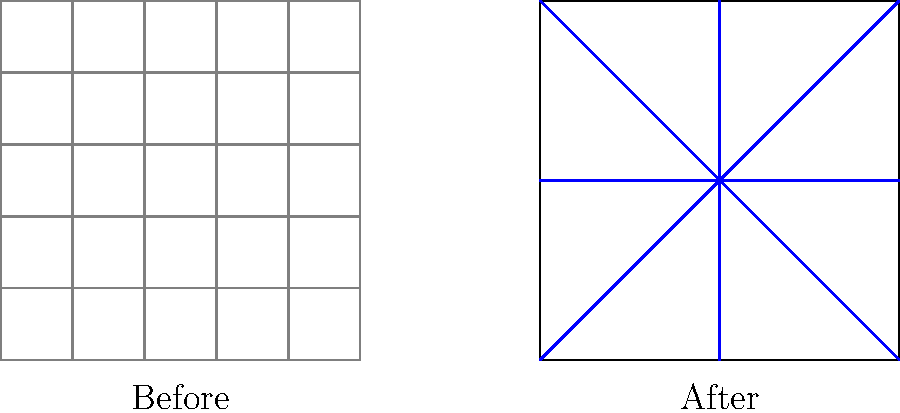In the evolution of urban planning principles, what key concept is illustrated by the transition from the "Before" to the "After" city grid, and how does it potentially impact the functionality and aesthetics of the urban environment? 1. Observe the "Before" grid:
   - It shows a rigid, rectangular grid system with uniform blocks.
   - This represents traditional grid planning, common in many cities.

2. Examine the "After" grid:
   - It introduces diagonal streets intersecting the grid.
   - The central area forms a star-like pattern.

3. Identify the key concept:
   - The introduction of diagonal streets represents the concept of "radiating avenues."
   - This is characteristic of Baroque urban planning principles.

4. Understand the impacts:
   - Functionality:
     a) Improved traffic flow by providing direct routes across the city.
     b) Creation of focal points at intersections, suitable for landmarks or public spaces.
   - Aesthetics:
     a) Breaks monotony of the grid, creating visual interest.
     b) Allows for grand vistas along the diagonal streets.

5. Historical context:
   - This transition is reminiscent of Haussmann's renovation of Paris or L'Enfant's plan for Washington, D.C.
   - It represents a shift from purely utilitarian planning to one that considers monumental aesthetics and efficient circulation.

6. Modern implications:
   - While not always directly copied, these principles continue to influence contemporary urban design.
   - They demonstrate the importance of balancing efficiency with visual appeal in city planning.
Answer: Radiating avenues 